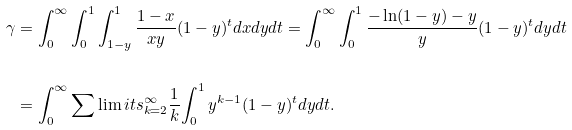Convert formula to latex. <formula><loc_0><loc_0><loc_500><loc_500>\gamma & = { \int _ { 0 } ^ { \infty } { { \int _ { 0 } ^ { 1 } { { \int _ { 1 - y } ^ { 1 } { { \frac { 1 - x } { x y } } ( 1 - y ) ^ { t } d x d y } } } } d t } } = { \int _ { 0 } ^ { \infty } { { \int _ { 0 } ^ { 1 } { { \frac { - \ln ( 1 - y ) - y } { y } } ( 1 - y ) ^ { t } } } d y d t } } \\ \\ & = { \int _ { 0 } ^ { \infty } { { \sum \lim i t s _ { k = 2 } ^ { \infty } { { \frac { 1 } { k } } { \int _ { 0 } ^ { 1 } { y ^ { k - 1 } ( 1 - y ) ^ { t } d y d t } } } } } } .</formula> 